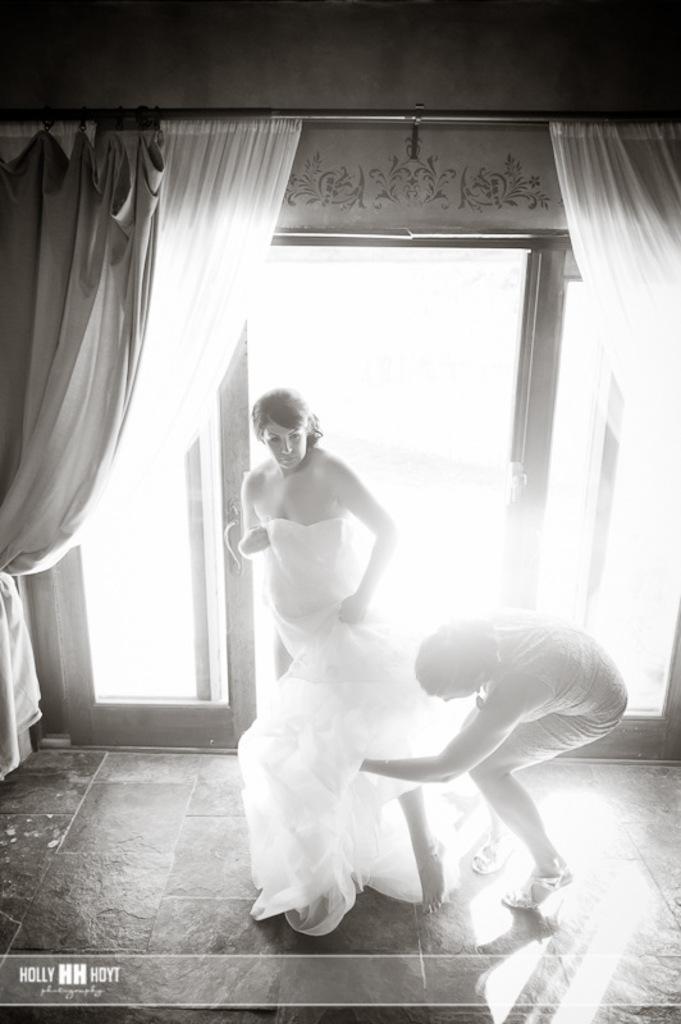Describe this image in one or two sentences. Here in this picture we can see a person in a white colored dress standing on the floor and behind her we can see a woman adjusting her dress and beside them we can see glass doors present and we can also see curtains present on either sides. 